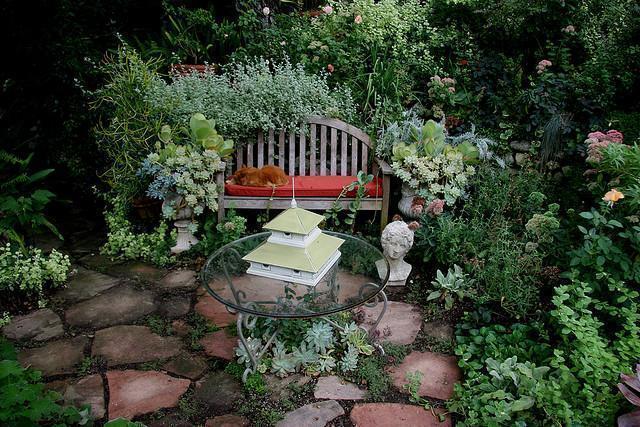What type of statue is to the right front of the bench?
Answer the question by selecting the correct answer among the 4 following choices and explain your choice with a short sentence. The answer should be formatted with the following format: `Answer: choice
Rationale: rationale.`
Options: Wooden, jade, bust, kinetic. Answer: bust.
Rationale: The statue on the right of the bench is called a bust and consists of just a face and neck 